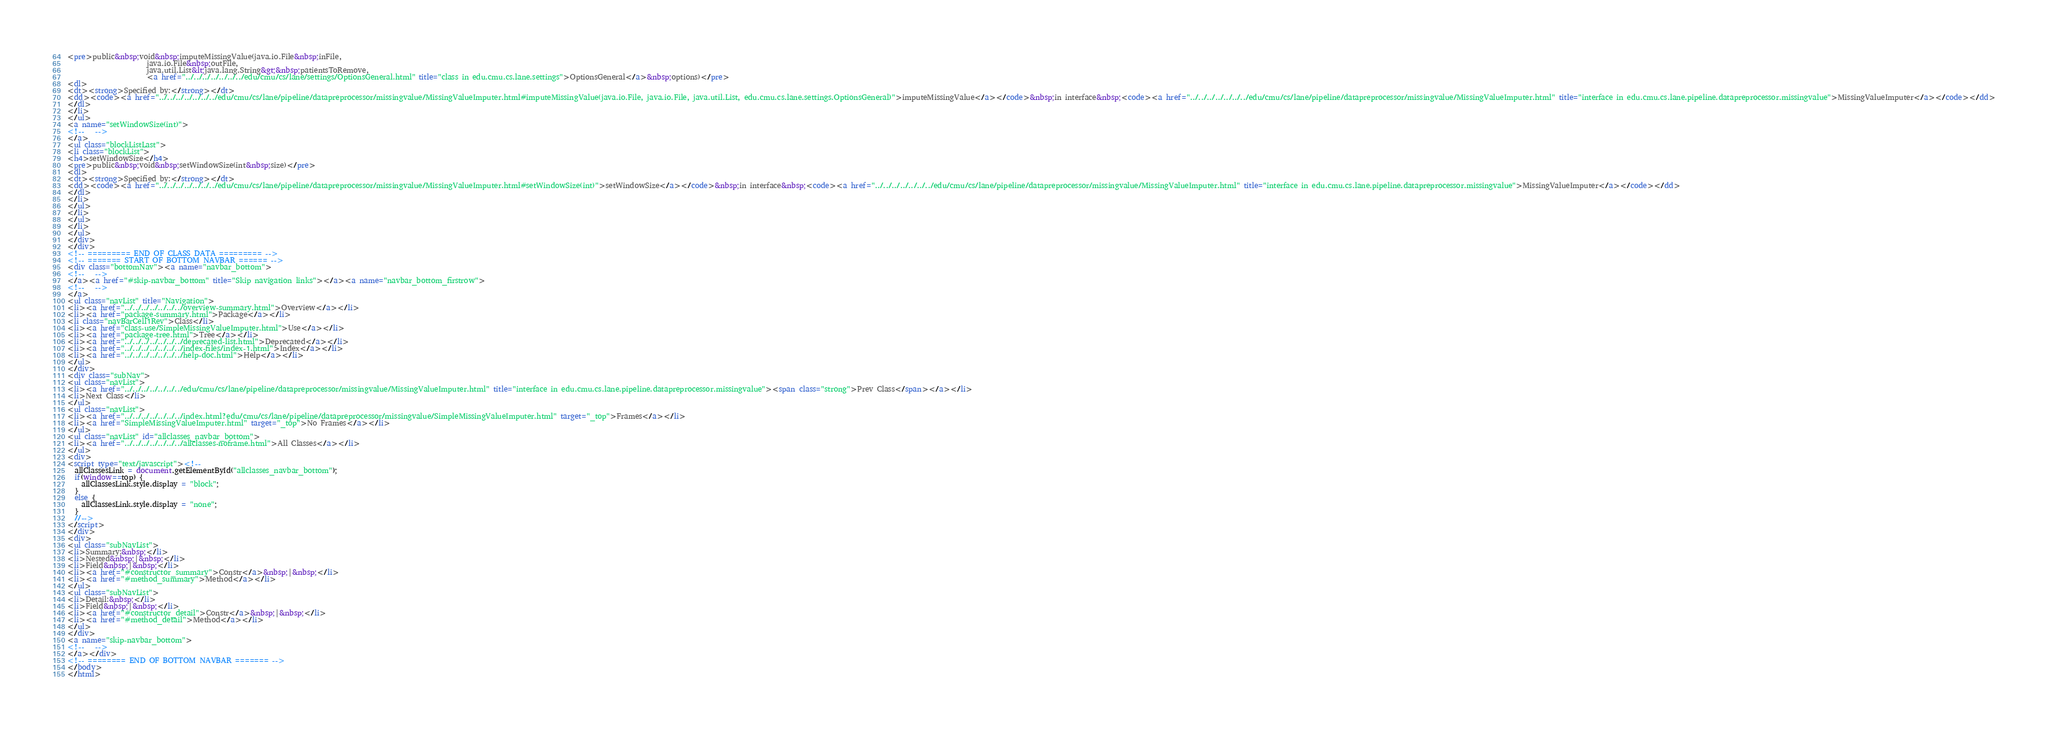<code> <loc_0><loc_0><loc_500><loc_500><_HTML_><pre>public&nbsp;void&nbsp;imputeMissingValue(java.io.File&nbsp;inFile,
                      java.io.File&nbsp;outFile,
                      java.util.List&lt;java.lang.String&gt;&nbsp;patientsToRemove,
                      <a href="../../../../../../../edu/cmu/cs/lane/settings/OptionsGeneral.html" title="class in edu.cmu.cs.lane.settings">OptionsGeneral</a>&nbsp;options)</pre>
<dl>
<dt><strong>Specified by:</strong></dt>
<dd><code><a href="../../../../../../../edu/cmu/cs/lane/pipeline/datapreprocessor/missingvalue/MissingValueImputer.html#imputeMissingValue(java.io.File, java.io.File, java.util.List, edu.cmu.cs.lane.settings.OptionsGeneral)">imputeMissingValue</a></code>&nbsp;in interface&nbsp;<code><a href="../../../../../../../edu/cmu/cs/lane/pipeline/datapreprocessor/missingvalue/MissingValueImputer.html" title="interface in edu.cmu.cs.lane.pipeline.datapreprocessor.missingvalue">MissingValueImputer</a></code></dd>
</dl>
</li>
</ul>
<a name="setWindowSize(int)">
<!--   -->
</a>
<ul class="blockListLast">
<li class="blockList">
<h4>setWindowSize</h4>
<pre>public&nbsp;void&nbsp;setWindowSize(int&nbsp;size)</pre>
<dl>
<dt><strong>Specified by:</strong></dt>
<dd><code><a href="../../../../../../../edu/cmu/cs/lane/pipeline/datapreprocessor/missingvalue/MissingValueImputer.html#setWindowSize(int)">setWindowSize</a></code>&nbsp;in interface&nbsp;<code><a href="../../../../../../../edu/cmu/cs/lane/pipeline/datapreprocessor/missingvalue/MissingValueImputer.html" title="interface in edu.cmu.cs.lane.pipeline.datapreprocessor.missingvalue">MissingValueImputer</a></code></dd>
</dl>
</li>
</ul>
</li>
</ul>
</li>
</ul>
</div>
</div>
<!-- ========= END OF CLASS DATA ========= -->
<!-- ======= START OF BOTTOM NAVBAR ====== -->
<div class="bottomNav"><a name="navbar_bottom">
<!--   -->
</a><a href="#skip-navbar_bottom" title="Skip navigation links"></a><a name="navbar_bottom_firstrow">
<!--   -->
</a>
<ul class="navList" title="Navigation">
<li><a href="../../../../../../../overview-summary.html">Overview</a></li>
<li><a href="package-summary.html">Package</a></li>
<li class="navBarCell1Rev">Class</li>
<li><a href="class-use/SimpleMissingValueImputer.html">Use</a></li>
<li><a href="package-tree.html">Tree</a></li>
<li><a href="../../../../../../../deprecated-list.html">Deprecated</a></li>
<li><a href="../../../../../../../index-files/index-1.html">Index</a></li>
<li><a href="../../../../../../../help-doc.html">Help</a></li>
</ul>
</div>
<div class="subNav">
<ul class="navList">
<li><a href="../../../../../../../edu/cmu/cs/lane/pipeline/datapreprocessor/missingvalue/MissingValueImputer.html" title="interface in edu.cmu.cs.lane.pipeline.datapreprocessor.missingvalue"><span class="strong">Prev Class</span></a></li>
<li>Next Class</li>
</ul>
<ul class="navList">
<li><a href="../../../../../../../index.html?edu/cmu/cs/lane/pipeline/datapreprocessor/missingvalue/SimpleMissingValueImputer.html" target="_top">Frames</a></li>
<li><a href="SimpleMissingValueImputer.html" target="_top">No Frames</a></li>
</ul>
<ul class="navList" id="allclasses_navbar_bottom">
<li><a href="../../../../../../../allclasses-noframe.html">All Classes</a></li>
</ul>
<div>
<script type="text/javascript"><!--
  allClassesLink = document.getElementById("allclasses_navbar_bottom");
  if(window==top) {
    allClassesLink.style.display = "block";
  }
  else {
    allClassesLink.style.display = "none";
  }
  //-->
</script>
</div>
<div>
<ul class="subNavList">
<li>Summary:&nbsp;</li>
<li>Nested&nbsp;|&nbsp;</li>
<li>Field&nbsp;|&nbsp;</li>
<li><a href="#constructor_summary">Constr</a>&nbsp;|&nbsp;</li>
<li><a href="#method_summary">Method</a></li>
</ul>
<ul class="subNavList">
<li>Detail:&nbsp;</li>
<li>Field&nbsp;|&nbsp;</li>
<li><a href="#constructor_detail">Constr</a>&nbsp;|&nbsp;</li>
<li><a href="#method_detail">Method</a></li>
</ul>
</div>
<a name="skip-navbar_bottom">
<!--   -->
</a></div>
<!-- ======== END OF BOTTOM NAVBAR ======= -->
</body>
</html>
</code> 